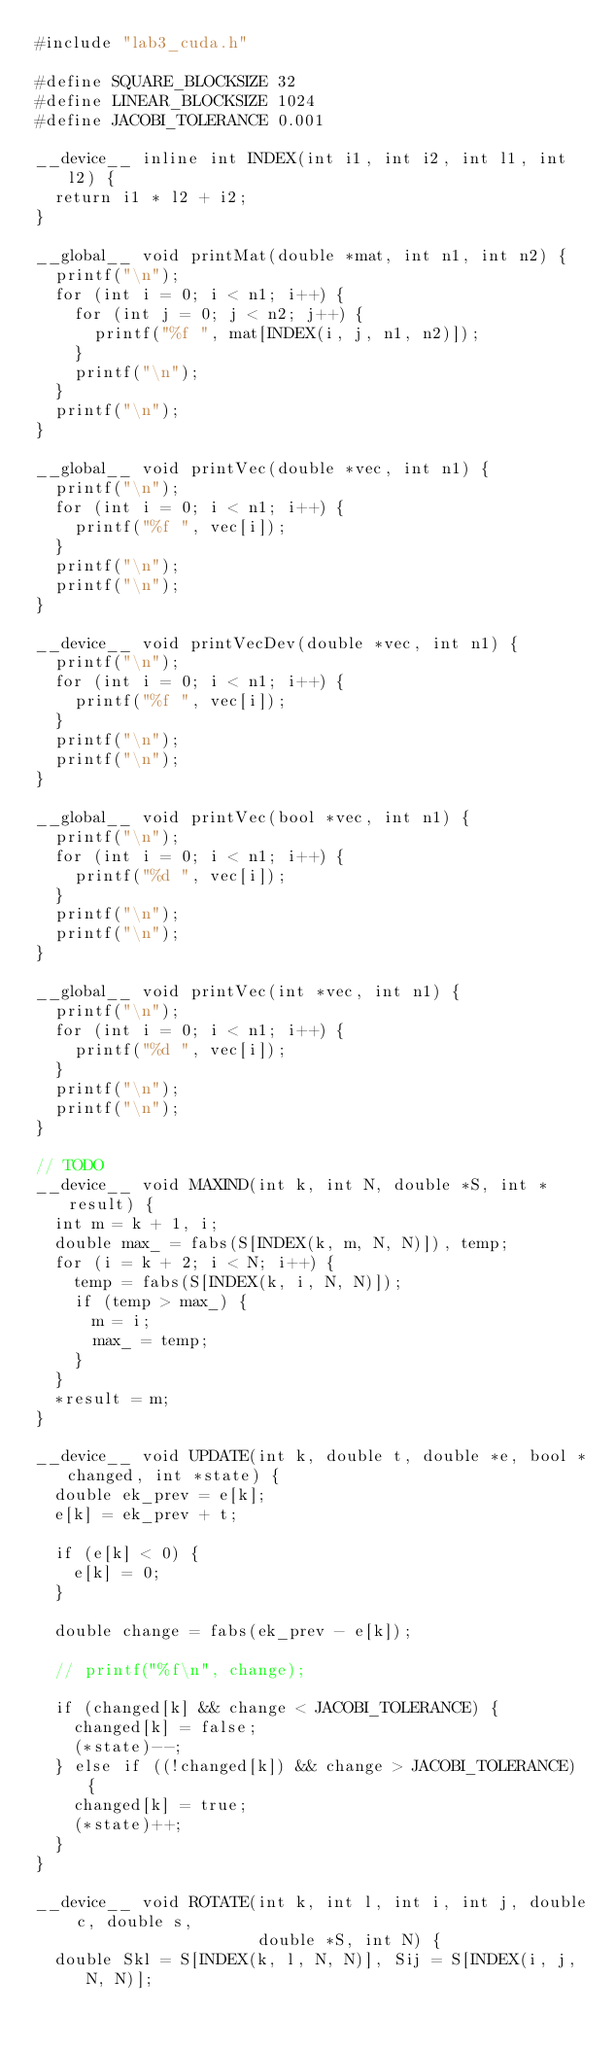Convert code to text. <code><loc_0><loc_0><loc_500><loc_500><_Cuda_>#include "lab3_cuda.h"

#define SQUARE_BLOCKSIZE 32
#define LINEAR_BLOCKSIZE 1024
#define JACOBI_TOLERANCE 0.001

__device__ inline int INDEX(int i1, int i2, int l1, int l2) {
  return i1 * l2 + i2;
}

__global__ void printMat(double *mat, int n1, int n2) {
  printf("\n");
  for (int i = 0; i < n1; i++) {
    for (int j = 0; j < n2; j++) {
      printf("%f ", mat[INDEX(i, j, n1, n2)]);
    }
    printf("\n");
  }
  printf("\n");
}

__global__ void printVec(double *vec, int n1) {
  printf("\n");
  for (int i = 0; i < n1; i++) {
    printf("%f ", vec[i]);
  }
  printf("\n");
  printf("\n");
}

__device__ void printVecDev(double *vec, int n1) {
  printf("\n");
  for (int i = 0; i < n1; i++) {
    printf("%f ", vec[i]);
  }
  printf("\n");
  printf("\n");
}

__global__ void printVec(bool *vec, int n1) {
  printf("\n");
  for (int i = 0; i < n1; i++) {
    printf("%d ", vec[i]);
  }
  printf("\n");
  printf("\n");
}

__global__ void printVec(int *vec, int n1) {
  printf("\n");
  for (int i = 0; i < n1; i++) {
    printf("%d ", vec[i]);
  }
  printf("\n");
  printf("\n");
}

// TODO
__device__ void MAXIND(int k, int N, double *S, int *result) {
  int m = k + 1, i;
  double max_ = fabs(S[INDEX(k, m, N, N)]), temp;
  for (i = k + 2; i < N; i++) {
    temp = fabs(S[INDEX(k, i, N, N)]);
    if (temp > max_) {
      m = i;
      max_ = temp;
    }
  }
  *result = m;
}

__device__ void UPDATE(int k, double t, double *e, bool *changed, int *state) {
  double ek_prev = e[k];
  e[k] = ek_prev + t;

  if (e[k] < 0) {
    e[k] = 0;
  }

  double change = fabs(ek_prev - e[k]);

  // printf("%f\n", change);

  if (changed[k] && change < JACOBI_TOLERANCE) {
    changed[k] = false;
    (*state)--;
  } else if ((!changed[k]) && change > JACOBI_TOLERANCE) {
    changed[k] = true;
    (*state)++;
  }
}

__device__ void ROTATE(int k, int l, int i, int j, double c, double s,
                       double *S, int N) {
  double Skl = S[INDEX(k, l, N, N)], Sij = S[INDEX(i, j, N, N)];</code> 